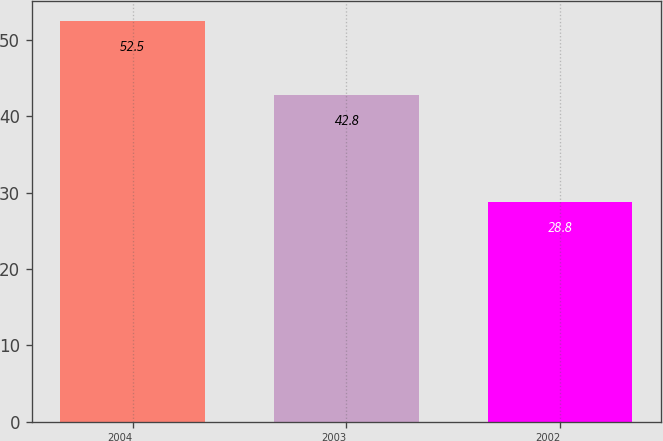Convert chart. <chart><loc_0><loc_0><loc_500><loc_500><bar_chart><fcel>2004<fcel>2003<fcel>2002<nl><fcel>52.5<fcel>42.8<fcel>28.8<nl></chart> 